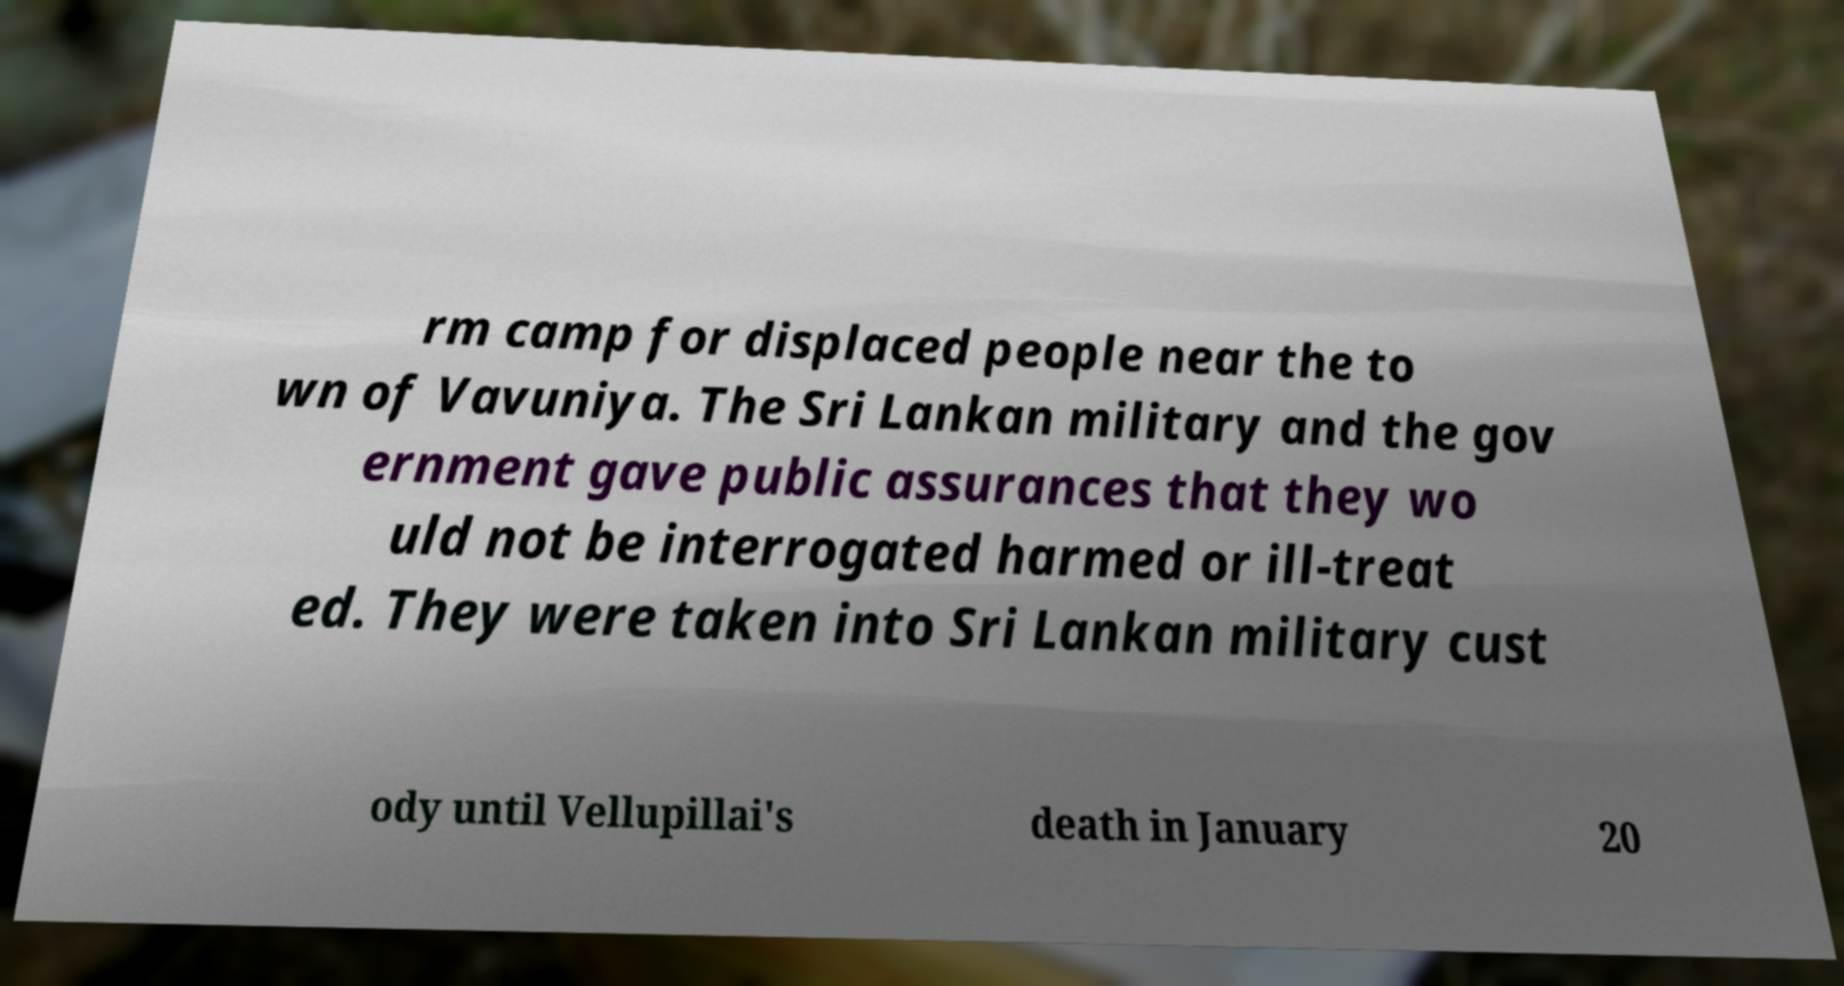What messages or text are displayed in this image? I need them in a readable, typed format. rm camp for displaced people near the to wn of Vavuniya. The Sri Lankan military and the gov ernment gave public assurances that they wo uld not be interrogated harmed or ill-treat ed. They were taken into Sri Lankan military cust ody until Vellupillai's death in January 20 